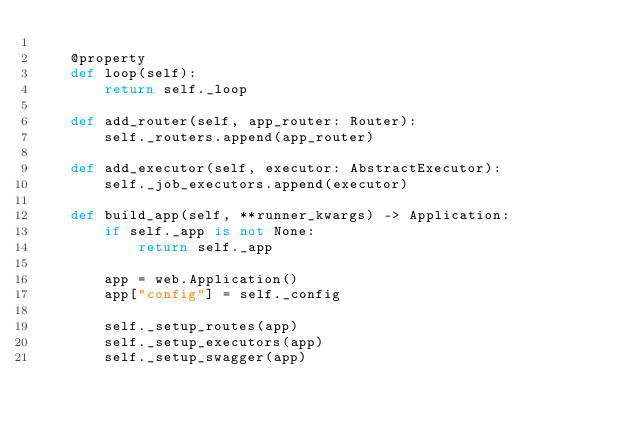<code> <loc_0><loc_0><loc_500><loc_500><_Python_>
    @property
    def loop(self):
        return self._loop

    def add_router(self, app_router: Router):
        self._routers.append(app_router)

    def add_executor(self, executor: AbstractExecutor):
        self._job_executors.append(executor)

    def build_app(self, **runner_kwargs) -> Application:
        if self._app is not None:
            return self._app

        app = web.Application()
        app["config"] = self._config

        self._setup_routes(app)
        self._setup_executors(app)
        self._setup_swagger(app)
</code> 